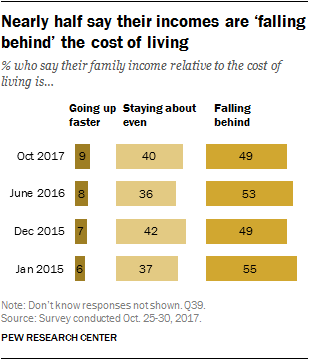Draw attention to some important aspects in this diagram. In October 2017, 49% of respondents reported falling behind in their work due to a lack of resources. In October 2017, the ratio between staying even and falling behind was approximately 1.700694444... 